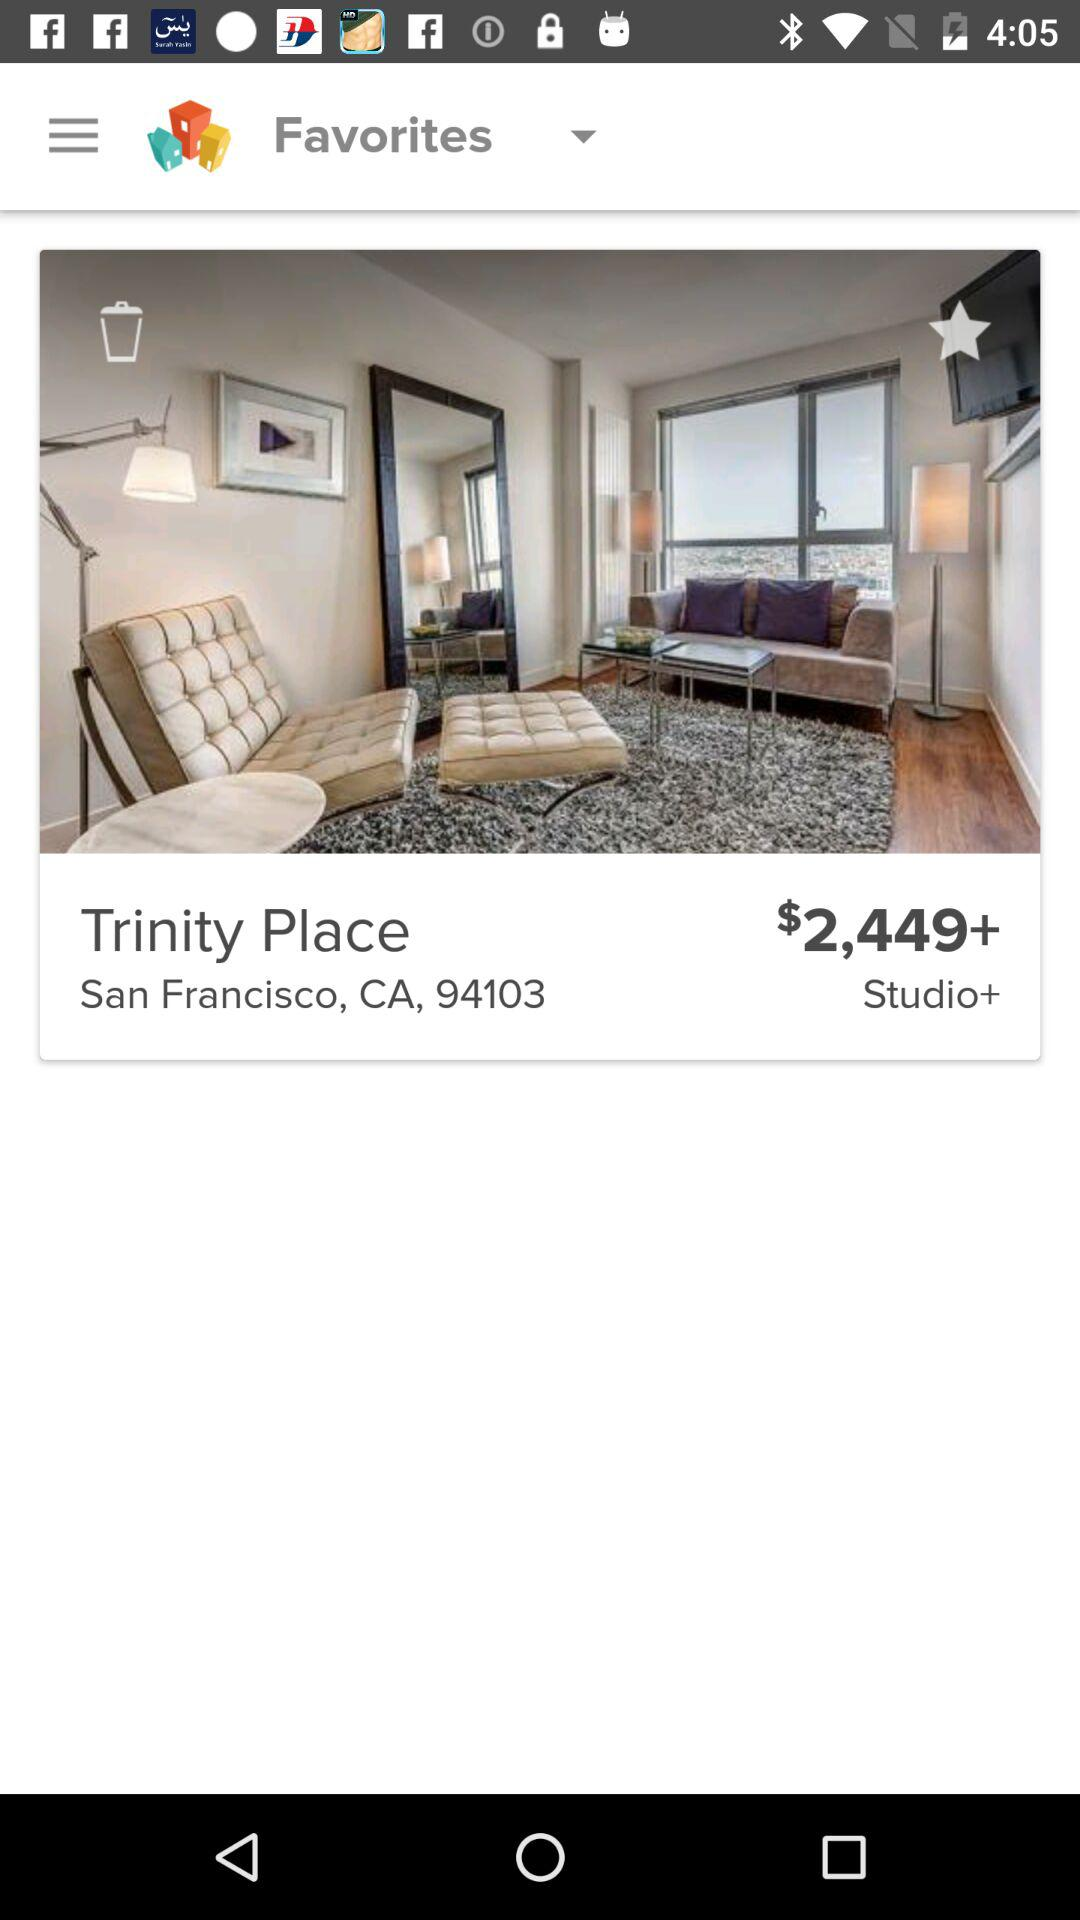What is the price? The price is $2,449+. 